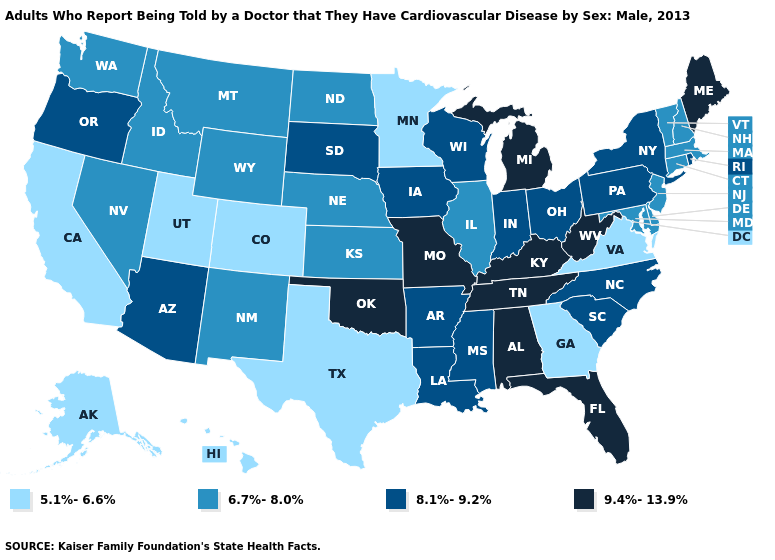Does North Carolina have a lower value than Tennessee?
Keep it brief. Yes. What is the lowest value in the MidWest?
Write a very short answer. 5.1%-6.6%. What is the value of South Dakota?
Give a very brief answer. 8.1%-9.2%. What is the value of Utah?
Quick response, please. 5.1%-6.6%. What is the value of Iowa?
Answer briefly. 8.1%-9.2%. What is the value of Florida?
Be succinct. 9.4%-13.9%. Does Kentucky have the highest value in the USA?
Give a very brief answer. Yes. Name the states that have a value in the range 8.1%-9.2%?
Give a very brief answer. Arizona, Arkansas, Indiana, Iowa, Louisiana, Mississippi, New York, North Carolina, Ohio, Oregon, Pennsylvania, Rhode Island, South Carolina, South Dakota, Wisconsin. Is the legend a continuous bar?
Keep it brief. No. What is the highest value in the USA?
Give a very brief answer. 9.4%-13.9%. Does the map have missing data?
Answer briefly. No. Among the states that border Florida , does Georgia have the highest value?
Short answer required. No. Among the states that border West Virginia , does Virginia have the highest value?
Short answer required. No. Name the states that have a value in the range 8.1%-9.2%?
Write a very short answer. Arizona, Arkansas, Indiana, Iowa, Louisiana, Mississippi, New York, North Carolina, Ohio, Oregon, Pennsylvania, Rhode Island, South Carolina, South Dakota, Wisconsin. 